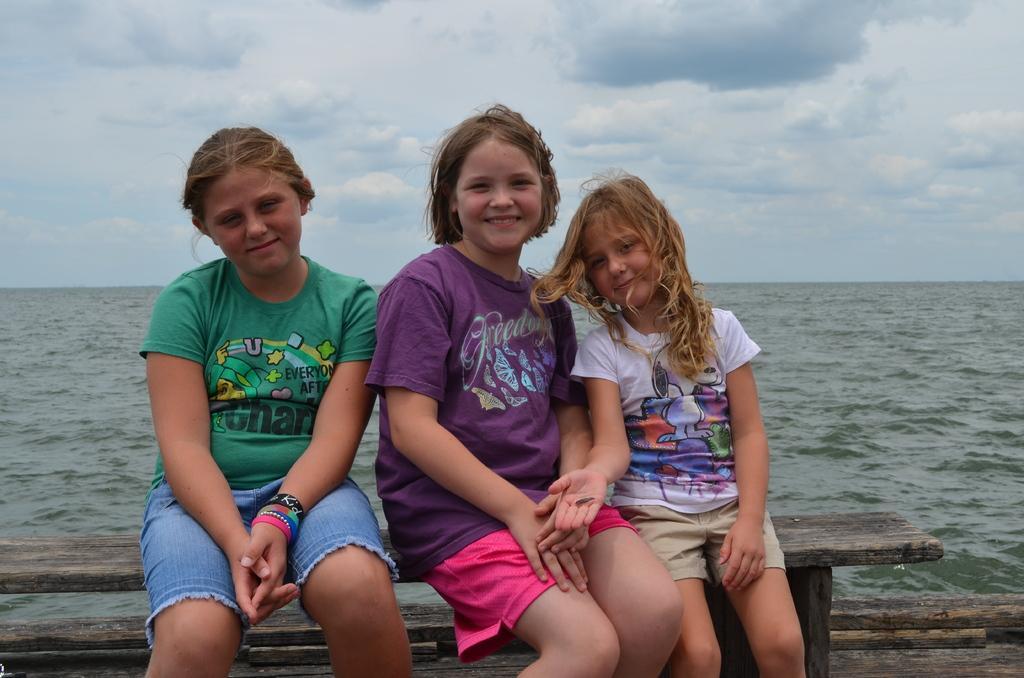Could you give a brief overview of what you see in this image? In the middle of the image three girls are sitting on a bench. Behind them there is water. At the top of the image there are some clouds in the sky. 